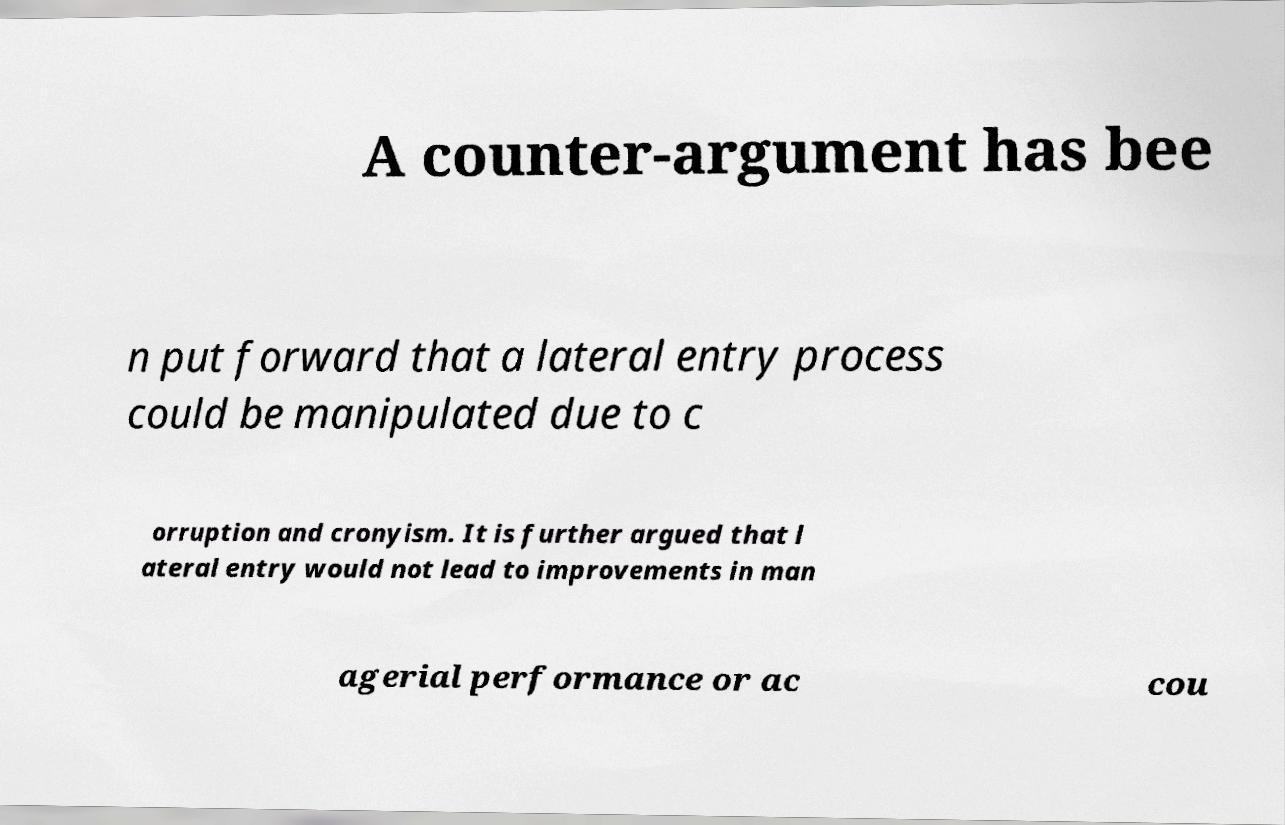Could you assist in decoding the text presented in this image and type it out clearly? A counter-argument has bee n put forward that a lateral entry process could be manipulated due to c orruption and cronyism. It is further argued that l ateral entry would not lead to improvements in man agerial performance or ac cou 